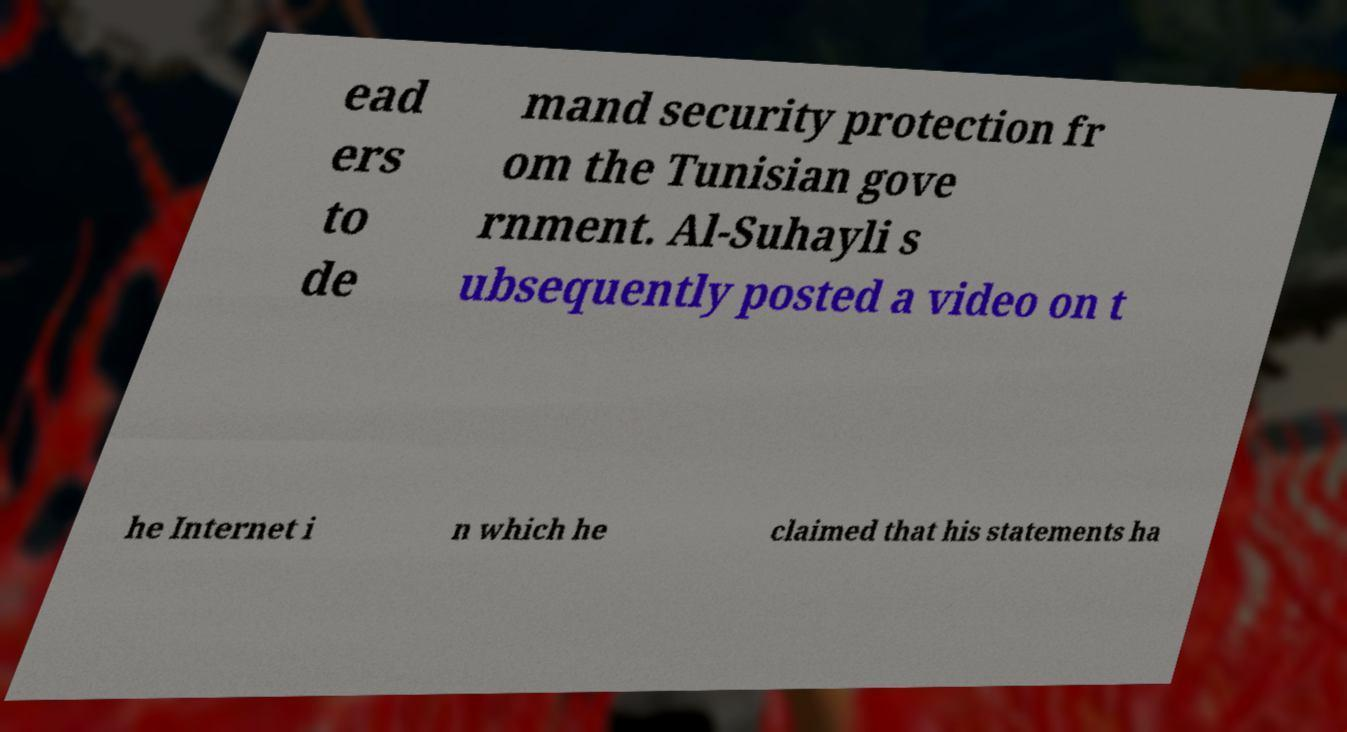I need the written content from this picture converted into text. Can you do that? ead ers to de mand security protection fr om the Tunisian gove rnment. Al-Suhayli s ubsequently posted a video on t he Internet i n which he claimed that his statements ha 